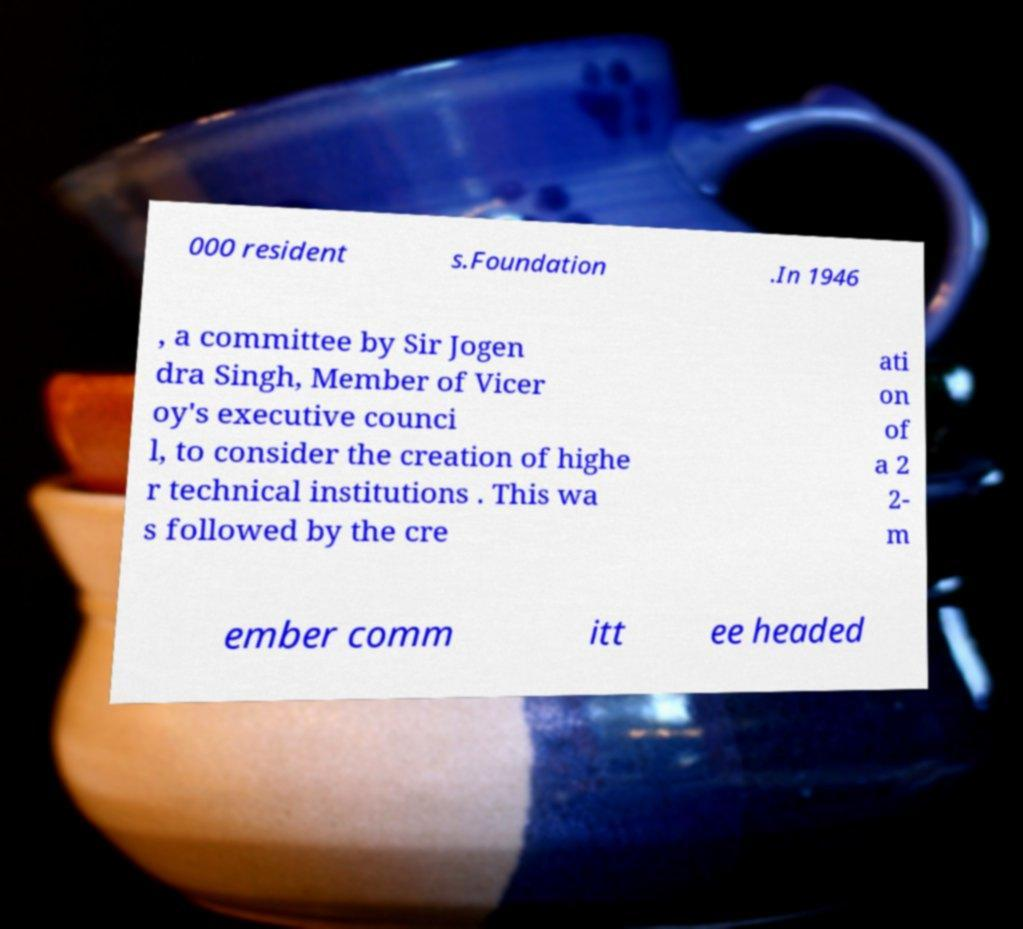Please read and relay the text visible in this image. What does it say? 000 resident s.Foundation .In 1946 , a committee by Sir Jogen dra Singh, Member of Vicer oy's executive counci l, to consider the creation of highe r technical institutions . This wa s followed by the cre ati on of a 2 2- m ember comm itt ee headed 